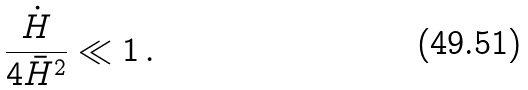Convert formula to latex. <formula><loc_0><loc_0><loc_500><loc_500>\frac { \dot { H } } { 4 \bar { H } ^ { 2 } } \ll 1 \, .</formula> 